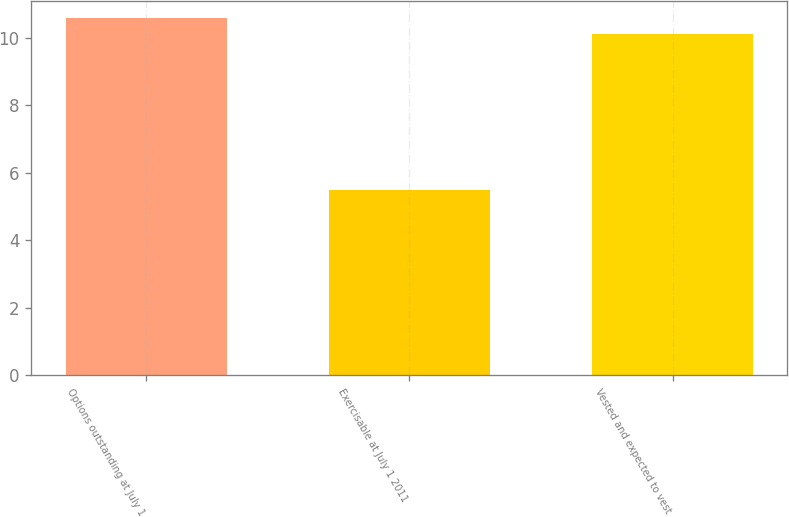Convert chart. <chart><loc_0><loc_0><loc_500><loc_500><bar_chart><fcel>Options outstanding at July 1<fcel>Exercisable at July 1 2011<fcel>Vested and expected to vest<nl><fcel>10.57<fcel>5.5<fcel>10.1<nl></chart> 